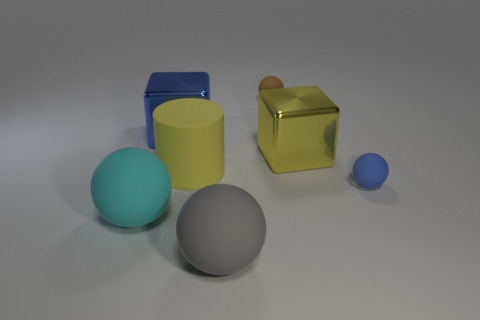What number of large rubber things have the same shape as the big blue metallic object?
Your answer should be compact. 0. The big shiny cube that is to the right of the tiny brown object is what color?
Provide a short and direct response. Yellow. What number of matte objects are cyan spheres or red cylinders?
Provide a succinct answer. 1. There is a big shiny thing that is the same color as the matte cylinder; what is its shape?
Your answer should be very brief. Cube. What number of cyan matte objects have the same size as the blue metallic cube?
Offer a very short reply. 1. What is the color of the large thing that is behind the gray rubber ball and on the right side of the large yellow cylinder?
Ensure brevity in your answer.  Yellow. What number of things are blue cubes or large yellow cylinders?
Make the answer very short. 2. How many tiny things are either brown matte balls or spheres?
Keep it short and to the point. 2. Is there anything else that is the same color as the cylinder?
Make the answer very short. Yes. How big is the object that is in front of the blue cube and behind the big matte cylinder?
Keep it short and to the point. Large. 